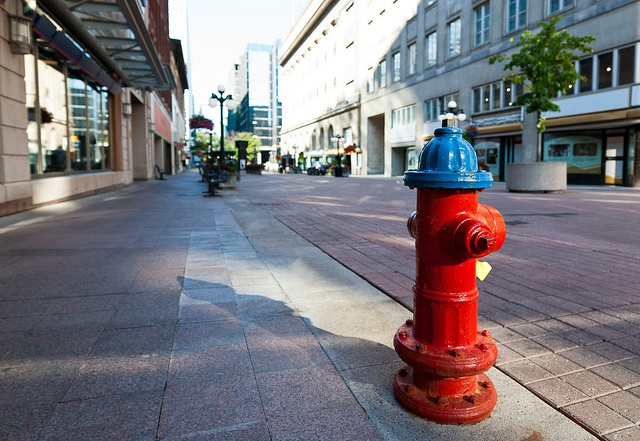Describe the objects in this image and their specific colors. I can see fire hydrant in maroon, black, brown, and red tones, potted plant in maroon, black, darkgreen, gray, and darkgray tones, bench in maroon, black, navy, and blue tones, and bench in maroon, gray, black, and purple tones in this image. 